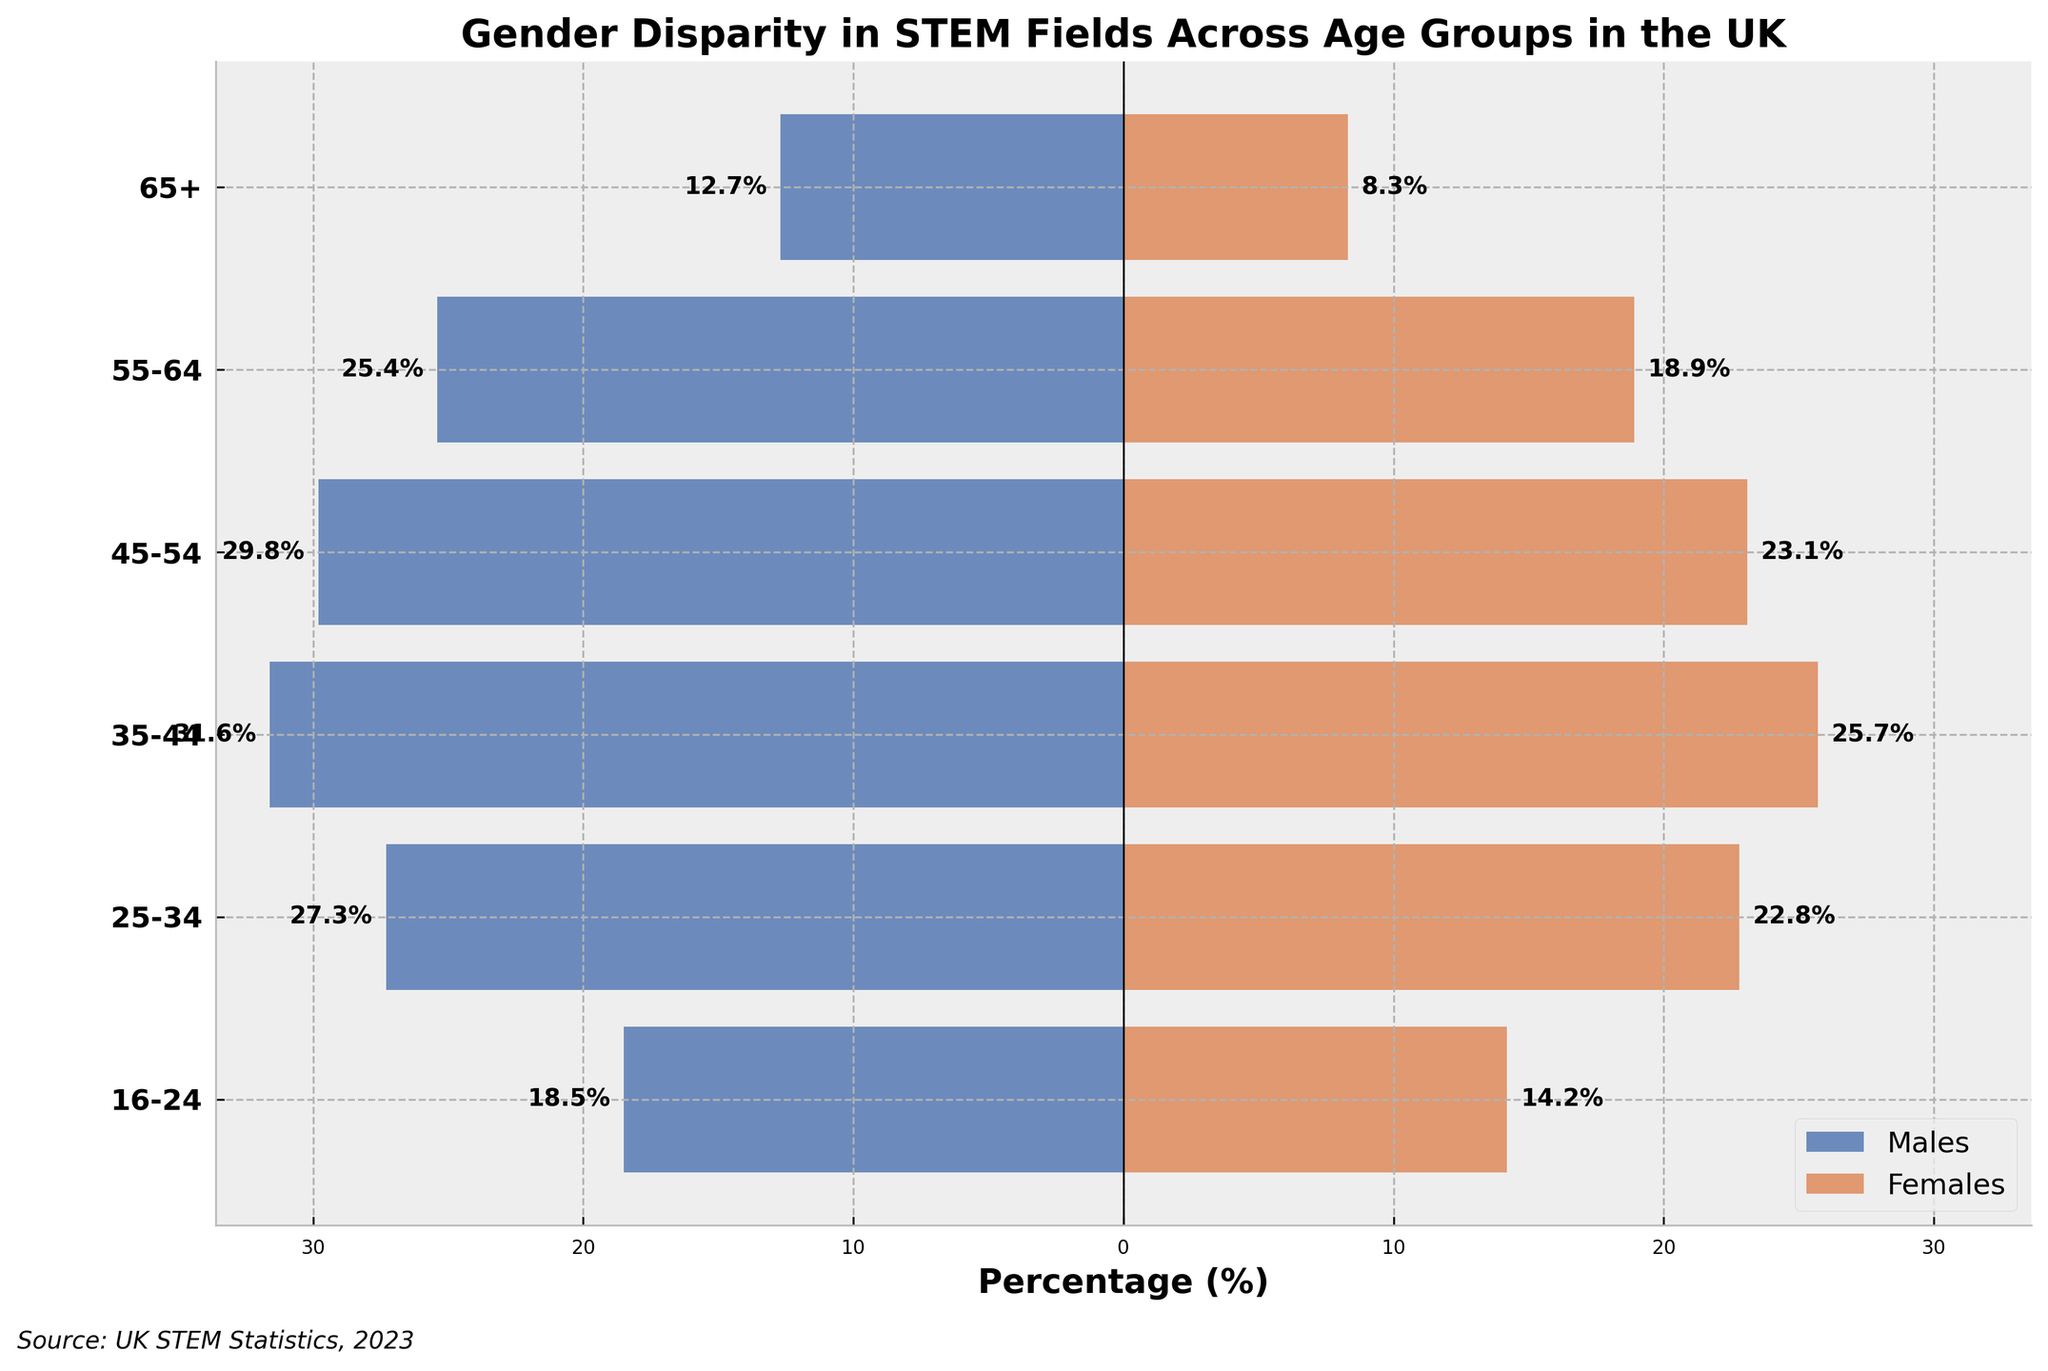What is the title of the figure? The title is located at the top of the figure. It is "Gender Disparity in STEM Fields Across Age Groups in the UK".
Answer: Gender Disparity in STEM Fields Across Age Groups in the UK What colors represent males and females in the figure? Males are represented by blue bars, and females are represented by orange bars.
Answer: Blue for males, orange for females How many age groups are depicted in the figure? The y-axis lists the age groups. There are six age groups depicted in the figure: 16-24, 25-34, 35-44, 45-54, 55-64, and 65+.
Answer: Six In which age group is the gender disparity the largest? To determine the largest disparity, compare the difference between the percentage of males and females across all age groups. The 35-44 age group has the largest disparity as males (31.6%) are more compared to females (25.7%).
Answer: 35-44 What is the percentage of females in the 55-64 age group? Look at the bar corresponding to the 55-64 age group under the females' color (orange). The number text or the length of the bar shows it is 18.9%.
Answer: 18.9% Which age group has the smallest percentage of males? Compare the percentages of males across all age groups. The age group 65+ has the smallest percentage of males, which is 12.7%.
Answer: 65+ What is the combined percentage of males and females in the 25-34 age group? Add the percentage of males and females for the 25-34 age group: 27.3% (males) + 22.8% (females). Performing this addition gives 50.1%.
Answer: 50.1% How does the percentage of males in the 45-54 age group compare to that in the 35-44 age group? Compare the values: 29.8% for the 45-54 age group and 31.6% for the 35-44 age group. 29.8% is less than 31.6%.
Answer: Less than Which age group has the closest gender parity, and what are the respective percentages of males and females? To identify the closest gender parity, find the age group where the percentage difference between males and females is smallest. The 16-24 age group has males at 18.5% and females at 14.2%, a difference of 4.3%.
Answer: 16-24; 18.5% males, 14.2% females 